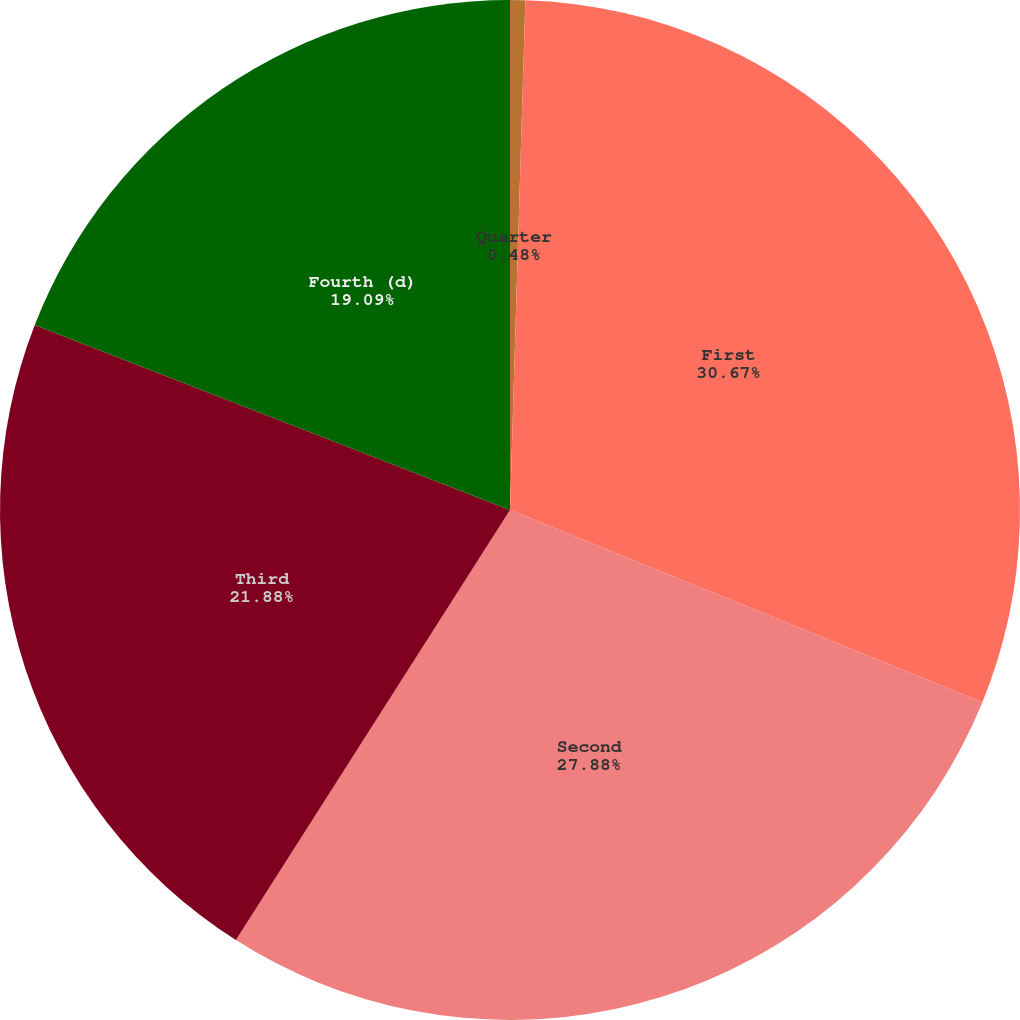Convert chart to OTSL. <chart><loc_0><loc_0><loc_500><loc_500><pie_chart><fcel>Quarter<fcel>First<fcel>Second<fcel>Third<fcel>Fourth (d)<nl><fcel>0.48%<fcel>30.67%<fcel>27.88%<fcel>21.88%<fcel>19.09%<nl></chart> 